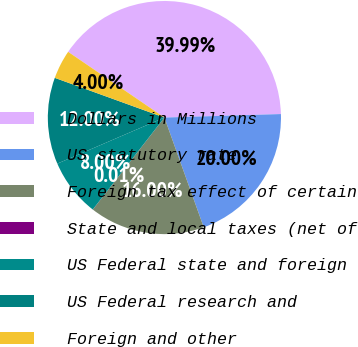<chart> <loc_0><loc_0><loc_500><loc_500><pie_chart><fcel>Dollars in Millions<fcel>US statutory rate<fcel>Foreign tax effect of certain<fcel>State and local taxes (net of<fcel>US Federal state and foreign<fcel>US Federal research and<fcel>Foreign and other<nl><fcel>39.99%<fcel>20.0%<fcel>16.0%<fcel>0.01%<fcel>8.0%<fcel>12.0%<fcel>4.0%<nl></chart> 